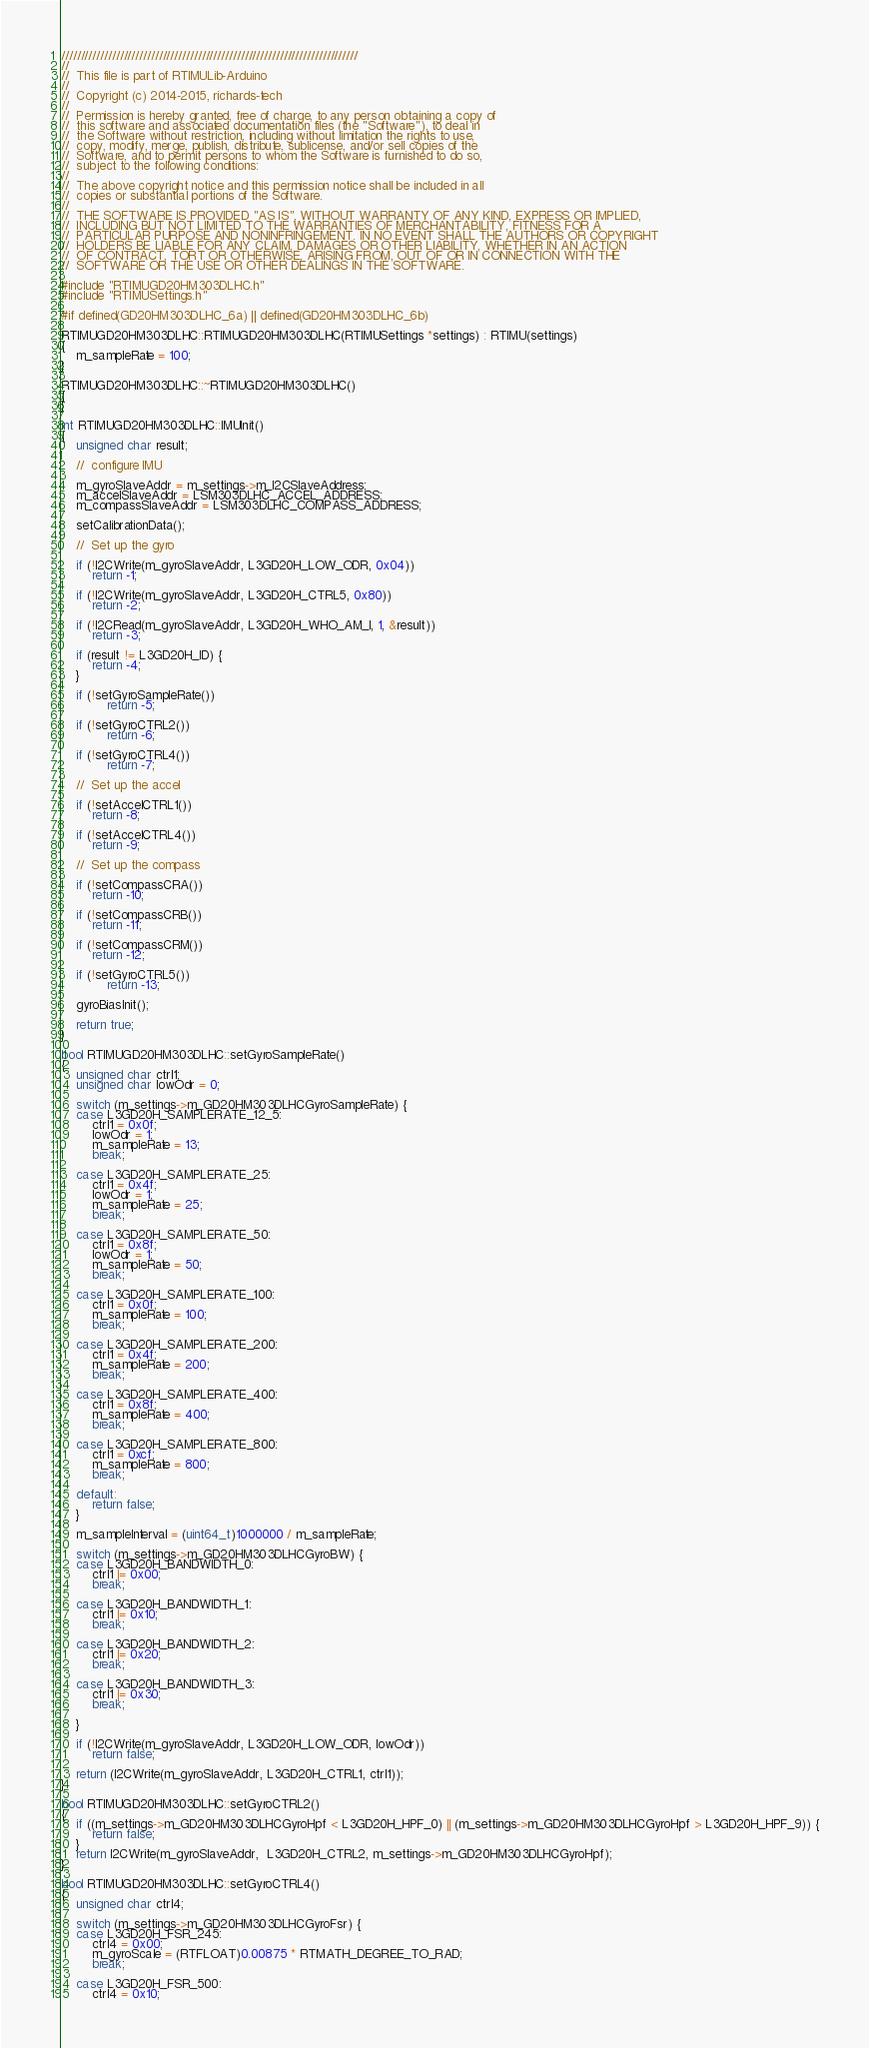<code> <loc_0><loc_0><loc_500><loc_500><_C++_>////////////////////////////////////////////////////////////////////////////
//
//  This file is part of RTIMULib-Arduino
//
//  Copyright (c) 2014-2015, richards-tech
//
//  Permission is hereby granted, free of charge, to any person obtaining a copy of
//  this software and associated documentation files (the "Software"), to deal in
//  the Software without restriction, including without limitation the rights to use,
//  copy, modify, merge, publish, distribute, sublicense, and/or sell copies of the
//  Software, and to permit persons to whom the Software is furnished to do so,
//  subject to the following conditions:
//
//  The above copyright notice and this permission notice shall be included in all
//  copies or substantial portions of the Software.
//
//  THE SOFTWARE IS PROVIDED "AS IS", WITHOUT WARRANTY OF ANY KIND, EXPRESS OR IMPLIED,
//  INCLUDING BUT NOT LIMITED TO THE WARRANTIES OF MERCHANTABILITY, FITNESS FOR A
//  PARTICULAR PURPOSE AND NONINFRINGEMENT. IN NO EVENT SHALL THE AUTHORS OR COPYRIGHT
//  HOLDERS BE LIABLE FOR ANY CLAIM, DAMAGES OR OTHER LIABILITY, WHETHER IN AN ACTION
//  OF CONTRACT, TORT OR OTHERWISE, ARISING FROM, OUT OF OR IN CONNECTION WITH THE
//  SOFTWARE OR THE USE OR OTHER DEALINGS IN THE SOFTWARE.

#include "RTIMUGD20HM303DLHC.h"
#include "RTIMUSettings.h"

#if defined(GD20HM303DLHC_6a) || defined(GD20HM303DLHC_6b)

RTIMUGD20HM303DLHC::RTIMUGD20HM303DLHC(RTIMUSettings *settings) : RTIMU(settings)
{
    m_sampleRate = 100;
}

RTIMUGD20HM303DLHC::~RTIMUGD20HM303DLHC()
{
}

int RTIMUGD20HM303DLHC::IMUInit()
{
    unsigned char result;

    //  configure IMU

    m_gyroSlaveAddr = m_settings->m_I2CSlaveAddress;
    m_accelSlaveAddr = LSM303DLHC_ACCEL_ADDRESS;
    m_compassSlaveAddr = LSM303DLHC_COMPASS_ADDRESS;

    setCalibrationData();

    //  Set up the gyro

    if (!I2CWrite(m_gyroSlaveAddr, L3GD20H_LOW_ODR, 0x04))
        return -1;

    if (!I2CWrite(m_gyroSlaveAddr, L3GD20H_CTRL5, 0x80))
        return -2;

    if (!I2CRead(m_gyroSlaveAddr, L3GD20H_WHO_AM_I, 1, &result))
        return -3;

    if (result != L3GD20H_ID) {
        return -4;
    }

    if (!setGyroSampleRate())
            return -5;

    if (!setGyroCTRL2())
            return -6;

    if (!setGyroCTRL4())
            return -7;

    //  Set up the accel

    if (!setAccelCTRL1())
        return -8;

    if (!setAccelCTRL4())
        return -9;

    //  Set up the compass

    if (!setCompassCRA())
        return -10;

    if (!setCompassCRB())
        return -11;

    if (!setCompassCRM())
        return -12;

    if (!setGyroCTRL5())
            return -13;

    gyroBiasInit();

    return true;
}

bool RTIMUGD20HM303DLHC::setGyroSampleRate()
{
    unsigned char ctrl1;
    unsigned char lowOdr = 0;

    switch (m_settings->m_GD20HM303DLHCGyroSampleRate) {
    case L3GD20H_SAMPLERATE_12_5:
        ctrl1 = 0x0f;
        lowOdr = 1;
        m_sampleRate = 13;
        break;

    case L3GD20H_SAMPLERATE_25:
        ctrl1 = 0x4f;
        lowOdr = 1;
        m_sampleRate = 25;
        break;

    case L3GD20H_SAMPLERATE_50:
        ctrl1 = 0x8f;
        lowOdr = 1;
        m_sampleRate = 50;
        break;

    case L3GD20H_SAMPLERATE_100:
        ctrl1 = 0x0f;
        m_sampleRate = 100;
        break;

    case L3GD20H_SAMPLERATE_200:
        ctrl1 = 0x4f;
        m_sampleRate = 200;
        break;

    case L3GD20H_SAMPLERATE_400:
        ctrl1 = 0x8f;
        m_sampleRate = 400;
        break;

    case L3GD20H_SAMPLERATE_800:
        ctrl1 = 0xcf;
        m_sampleRate = 800;
        break;

    default:
        return false;
    }

    m_sampleInterval = (uint64_t)1000000 / m_sampleRate;

    switch (m_settings->m_GD20HM303DLHCGyroBW) {
    case L3GD20H_BANDWIDTH_0:
        ctrl1 |= 0x00;
        break;

    case L3GD20H_BANDWIDTH_1:
        ctrl1 |= 0x10;
        break;

    case L3GD20H_BANDWIDTH_2:
        ctrl1 |= 0x20;
        break;

    case L3GD20H_BANDWIDTH_3:
        ctrl1 |= 0x30;
        break;

    }

    if (!I2CWrite(m_gyroSlaveAddr, L3GD20H_LOW_ODR, lowOdr))
        return false;

    return (I2CWrite(m_gyroSlaveAddr, L3GD20H_CTRL1, ctrl1));
}

bool RTIMUGD20HM303DLHC::setGyroCTRL2()
{
    if ((m_settings->m_GD20HM303DLHCGyroHpf < L3GD20H_HPF_0) || (m_settings->m_GD20HM303DLHCGyroHpf > L3GD20H_HPF_9)) {
        return false;
    }
    return I2CWrite(m_gyroSlaveAddr,  L3GD20H_CTRL2, m_settings->m_GD20HM303DLHCGyroHpf);
}

bool RTIMUGD20HM303DLHC::setGyroCTRL4()
{
    unsigned char ctrl4;

    switch (m_settings->m_GD20HM303DLHCGyroFsr) {
    case L3GD20H_FSR_245:
        ctrl4 = 0x00;
        m_gyroScale = (RTFLOAT)0.00875 * RTMATH_DEGREE_TO_RAD;
        break;

    case L3GD20H_FSR_500:
        ctrl4 = 0x10;</code> 